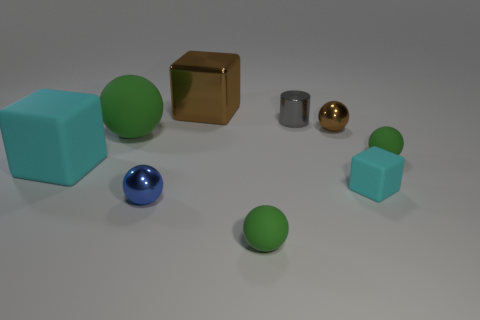Subtract all blue balls. How many balls are left? 4 Subtract all gray spheres. How many cyan cubes are left? 2 Subtract all blue balls. How many balls are left? 4 Subtract all cylinders. How many objects are left? 8 Subtract 3 spheres. How many spheres are left? 2 Subtract all tiny rubber balls. Subtract all tiny metallic cylinders. How many objects are left? 6 Add 4 brown things. How many brown things are left? 6 Add 9 big cyan rubber cubes. How many big cyan rubber cubes exist? 10 Subtract 1 brown cubes. How many objects are left? 8 Subtract all blue cubes. Subtract all blue balls. How many cubes are left? 3 